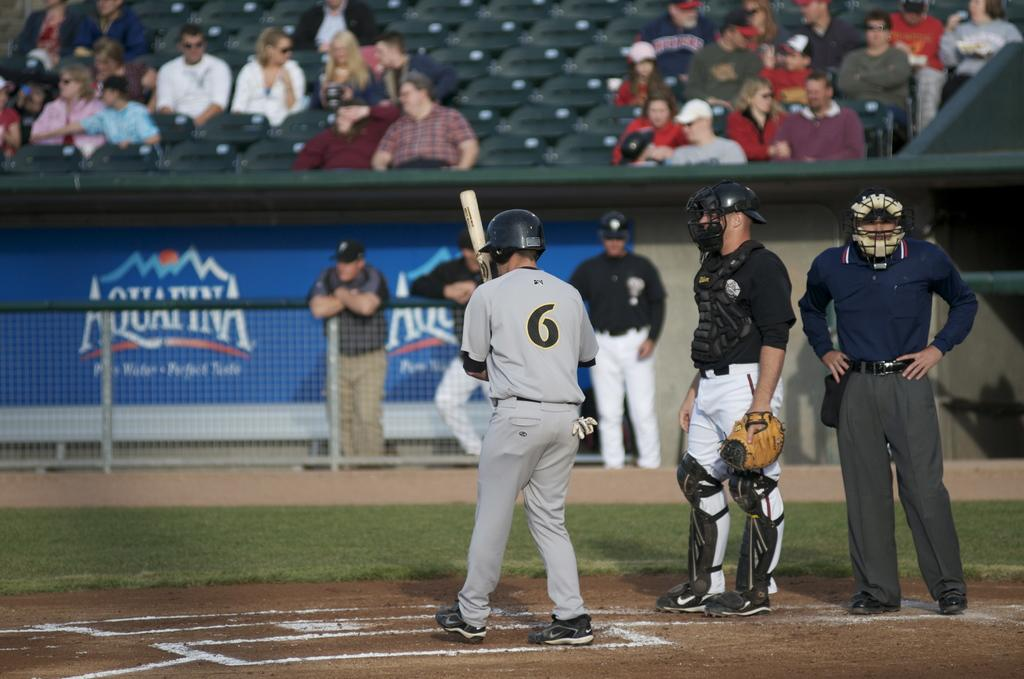Provide a one-sentence caption for the provided image. A batter stands at the mound across from an Aquafina logo on the stadium wall. 